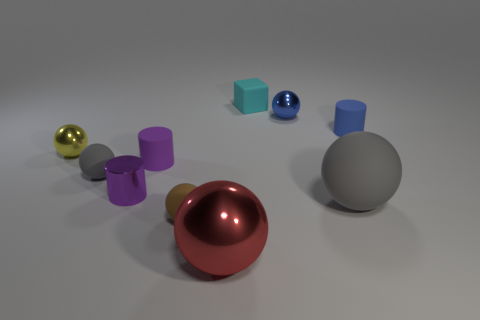What number of rubber cylinders have the same size as the cyan block?
Provide a succinct answer. 2. What number of shiny objects are either spheres or big red cubes?
Offer a very short reply. 3. What is the material of the tiny cyan cube?
Your answer should be very brief. Rubber. There is a matte block; how many metallic things are right of it?
Provide a succinct answer. 1. Are the gray thing that is to the right of the tiny purple matte thing and the red thing made of the same material?
Make the answer very short. No. What number of green rubber objects are the same shape as the small gray rubber object?
Your answer should be compact. 0. What number of small objects are blue matte things or shiny objects?
Your response must be concise. 4. There is a tiny matte object that is on the right side of the tiny blue metal object; is it the same color as the metal cylinder?
Offer a terse response. No. Is the color of the tiny rubber ball behind the tiny purple metallic cylinder the same as the small ball that is to the right of the red thing?
Your response must be concise. No. Is there another tiny ball that has the same material as the red ball?
Provide a succinct answer. Yes. 